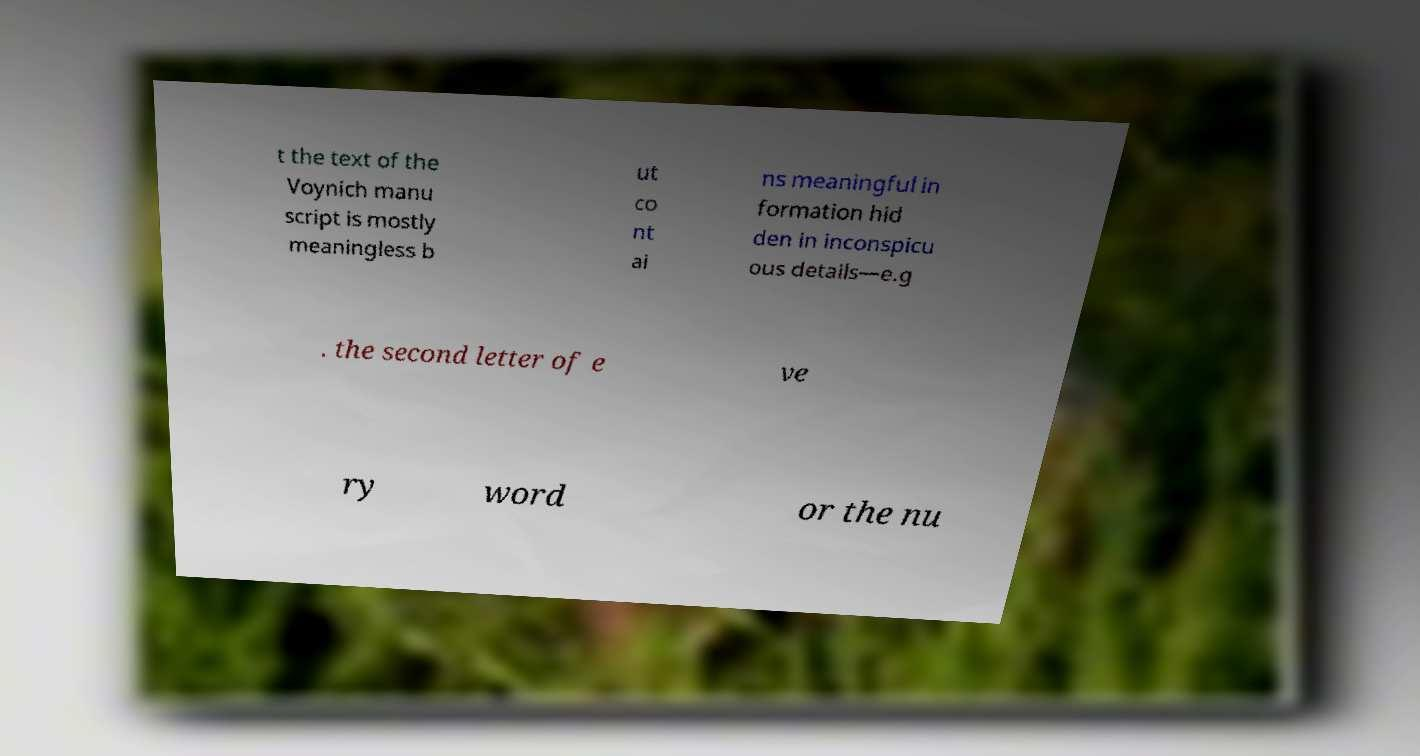Could you extract and type out the text from this image? t the text of the Voynich manu script is mostly meaningless b ut co nt ai ns meaningful in formation hid den in inconspicu ous details—e.g . the second letter of e ve ry word or the nu 